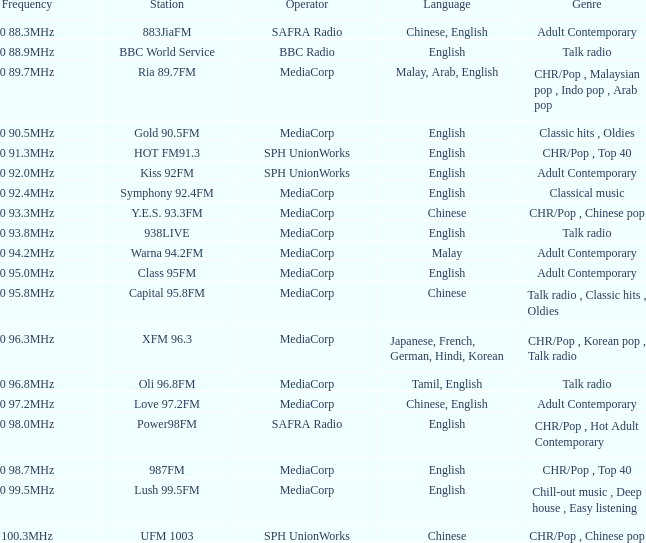Which station is managed by bbc radio in the talk radio genre? BBC World Service. 